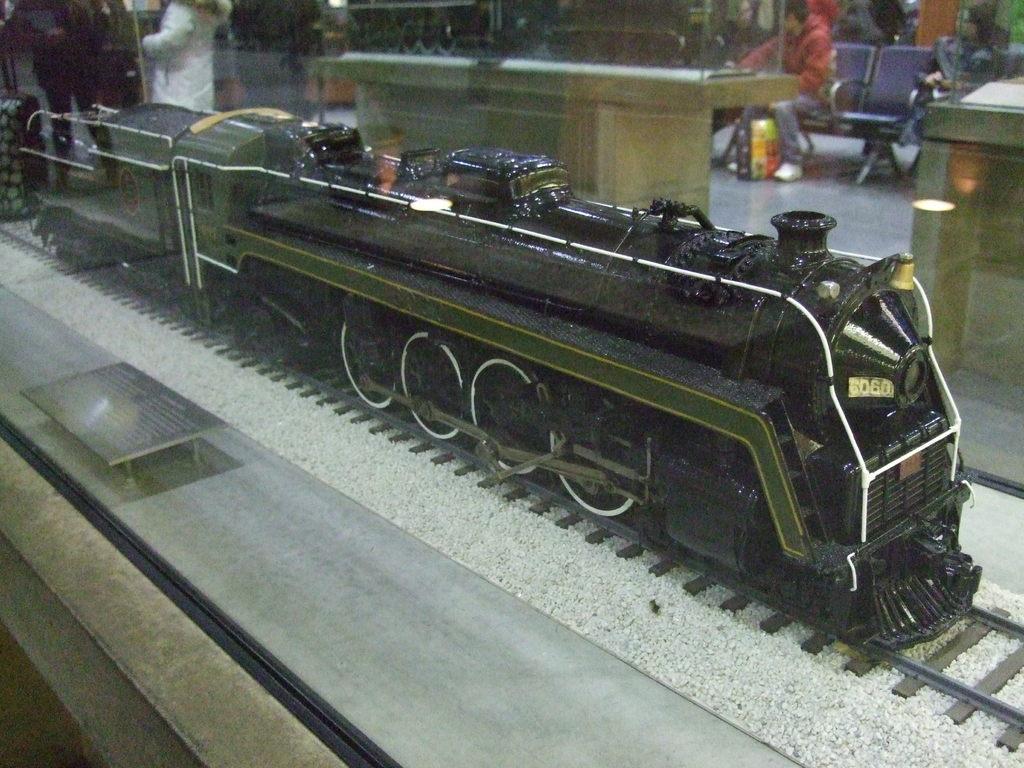Please provide a concise description of this image. We can see train on track and board on the surface. In the background we can see tables and few people are sitting on chairs and few people are standing. 